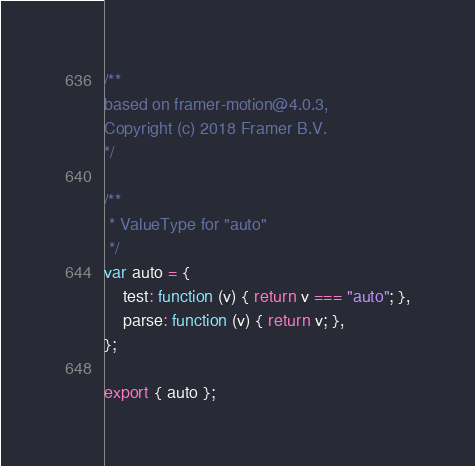Convert code to text. <code><loc_0><loc_0><loc_500><loc_500><_JavaScript_>/** 
based on framer-motion@4.0.3,
Copyright (c) 2018 Framer B.V.
*/

/**
 * ValueType for "auto"
 */
var auto = {
    test: function (v) { return v === "auto"; },
    parse: function (v) { return v; },
};

export { auto };
</code> 